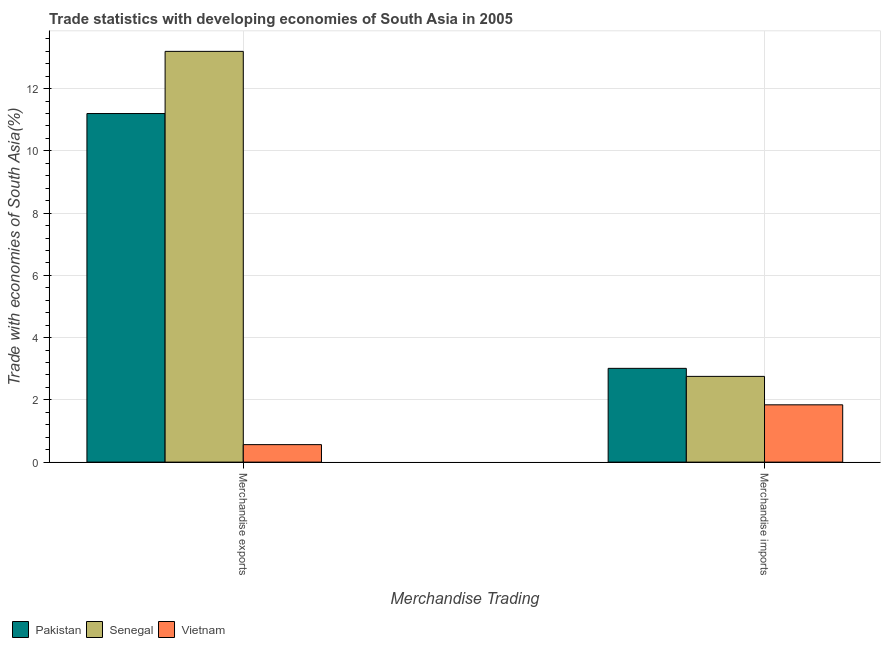How many bars are there on the 1st tick from the left?
Make the answer very short. 3. What is the label of the 2nd group of bars from the left?
Provide a short and direct response. Merchandise imports. What is the merchandise exports in Vietnam?
Offer a very short reply. 0.56. Across all countries, what is the maximum merchandise imports?
Your response must be concise. 3.01. Across all countries, what is the minimum merchandise exports?
Provide a succinct answer. 0.56. In which country was the merchandise imports maximum?
Provide a succinct answer. Pakistan. In which country was the merchandise exports minimum?
Make the answer very short. Vietnam. What is the total merchandise exports in the graph?
Offer a very short reply. 24.96. What is the difference between the merchandise imports in Pakistan and that in Vietnam?
Offer a terse response. 1.17. What is the difference between the merchandise exports in Pakistan and the merchandise imports in Vietnam?
Make the answer very short. 9.36. What is the average merchandise exports per country?
Offer a terse response. 8.32. What is the difference between the merchandise imports and merchandise exports in Senegal?
Make the answer very short. -10.44. In how many countries, is the merchandise imports greater than 13.2 %?
Your answer should be compact. 0. What is the ratio of the merchandise exports in Senegal to that in Pakistan?
Offer a very short reply. 1.18. What does the 3rd bar from the left in Merchandise imports represents?
Give a very brief answer. Vietnam. Are all the bars in the graph horizontal?
Offer a terse response. No. How many countries are there in the graph?
Make the answer very short. 3. Are the values on the major ticks of Y-axis written in scientific E-notation?
Ensure brevity in your answer.  No. Does the graph contain grids?
Keep it short and to the point. Yes. How many legend labels are there?
Give a very brief answer. 3. What is the title of the graph?
Offer a terse response. Trade statistics with developing economies of South Asia in 2005. Does "Grenada" appear as one of the legend labels in the graph?
Your response must be concise. No. What is the label or title of the X-axis?
Offer a terse response. Merchandise Trading. What is the label or title of the Y-axis?
Keep it short and to the point. Trade with economies of South Asia(%). What is the Trade with economies of South Asia(%) of Pakistan in Merchandise exports?
Offer a very short reply. 11.2. What is the Trade with economies of South Asia(%) of Senegal in Merchandise exports?
Your answer should be compact. 13.2. What is the Trade with economies of South Asia(%) in Vietnam in Merchandise exports?
Give a very brief answer. 0.56. What is the Trade with economies of South Asia(%) of Pakistan in Merchandise imports?
Your answer should be very brief. 3.01. What is the Trade with economies of South Asia(%) in Senegal in Merchandise imports?
Make the answer very short. 2.75. What is the Trade with economies of South Asia(%) of Vietnam in Merchandise imports?
Make the answer very short. 1.84. Across all Merchandise Trading, what is the maximum Trade with economies of South Asia(%) in Pakistan?
Give a very brief answer. 11.2. Across all Merchandise Trading, what is the maximum Trade with economies of South Asia(%) of Senegal?
Provide a succinct answer. 13.2. Across all Merchandise Trading, what is the maximum Trade with economies of South Asia(%) in Vietnam?
Keep it short and to the point. 1.84. Across all Merchandise Trading, what is the minimum Trade with economies of South Asia(%) in Pakistan?
Offer a terse response. 3.01. Across all Merchandise Trading, what is the minimum Trade with economies of South Asia(%) of Senegal?
Make the answer very short. 2.75. Across all Merchandise Trading, what is the minimum Trade with economies of South Asia(%) in Vietnam?
Ensure brevity in your answer.  0.56. What is the total Trade with economies of South Asia(%) of Pakistan in the graph?
Offer a terse response. 14.21. What is the total Trade with economies of South Asia(%) in Senegal in the graph?
Make the answer very short. 15.95. What is the total Trade with economies of South Asia(%) of Vietnam in the graph?
Offer a terse response. 2.4. What is the difference between the Trade with economies of South Asia(%) in Pakistan in Merchandise exports and that in Merchandise imports?
Offer a very short reply. 8.19. What is the difference between the Trade with economies of South Asia(%) in Senegal in Merchandise exports and that in Merchandise imports?
Keep it short and to the point. 10.44. What is the difference between the Trade with economies of South Asia(%) in Vietnam in Merchandise exports and that in Merchandise imports?
Offer a very short reply. -1.28. What is the difference between the Trade with economies of South Asia(%) in Pakistan in Merchandise exports and the Trade with economies of South Asia(%) in Senegal in Merchandise imports?
Give a very brief answer. 8.44. What is the difference between the Trade with economies of South Asia(%) of Pakistan in Merchandise exports and the Trade with economies of South Asia(%) of Vietnam in Merchandise imports?
Your answer should be compact. 9.36. What is the difference between the Trade with economies of South Asia(%) of Senegal in Merchandise exports and the Trade with economies of South Asia(%) of Vietnam in Merchandise imports?
Provide a succinct answer. 11.36. What is the average Trade with economies of South Asia(%) of Pakistan per Merchandise Trading?
Offer a very short reply. 7.11. What is the average Trade with economies of South Asia(%) of Senegal per Merchandise Trading?
Provide a short and direct response. 7.98. What is the average Trade with economies of South Asia(%) in Vietnam per Merchandise Trading?
Your answer should be very brief. 1.2. What is the difference between the Trade with economies of South Asia(%) in Pakistan and Trade with economies of South Asia(%) in Senegal in Merchandise exports?
Your answer should be very brief. -2. What is the difference between the Trade with economies of South Asia(%) of Pakistan and Trade with economies of South Asia(%) of Vietnam in Merchandise exports?
Ensure brevity in your answer.  10.64. What is the difference between the Trade with economies of South Asia(%) in Senegal and Trade with economies of South Asia(%) in Vietnam in Merchandise exports?
Provide a succinct answer. 12.63. What is the difference between the Trade with economies of South Asia(%) of Pakistan and Trade with economies of South Asia(%) of Senegal in Merchandise imports?
Keep it short and to the point. 0.26. What is the difference between the Trade with economies of South Asia(%) of Pakistan and Trade with economies of South Asia(%) of Vietnam in Merchandise imports?
Keep it short and to the point. 1.17. What is the difference between the Trade with economies of South Asia(%) of Senegal and Trade with economies of South Asia(%) of Vietnam in Merchandise imports?
Give a very brief answer. 0.91. What is the ratio of the Trade with economies of South Asia(%) of Pakistan in Merchandise exports to that in Merchandise imports?
Give a very brief answer. 3.72. What is the ratio of the Trade with economies of South Asia(%) of Senegal in Merchandise exports to that in Merchandise imports?
Your answer should be very brief. 4.79. What is the ratio of the Trade with economies of South Asia(%) of Vietnam in Merchandise exports to that in Merchandise imports?
Keep it short and to the point. 0.31. What is the difference between the highest and the second highest Trade with economies of South Asia(%) in Pakistan?
Offer a terse response. 8.19. What is the difference between the highest and the second highest Trade with economies of South Asia(%) in Senegal?
Provide a short and direct response. 10.44. What is the difference between the highest and the second highest Trade with economies of South Asia(%) in Vietnam?
Offer a very short reply. 1.28. What is the difference between the highest and the lowest Trade with economies of South Asia(%) in Pakistan?
Ensure brevity in your answer.  8.19. What is the difference between the highest and the lowest Trade with economies of South Asia(%) of Senegal?
Make the answer very short. 10.44. What is the difference between the highest and the lowest Trade with economies of South Asia(%) in Vietnam?
Provide a short and direct response. 1.28. 